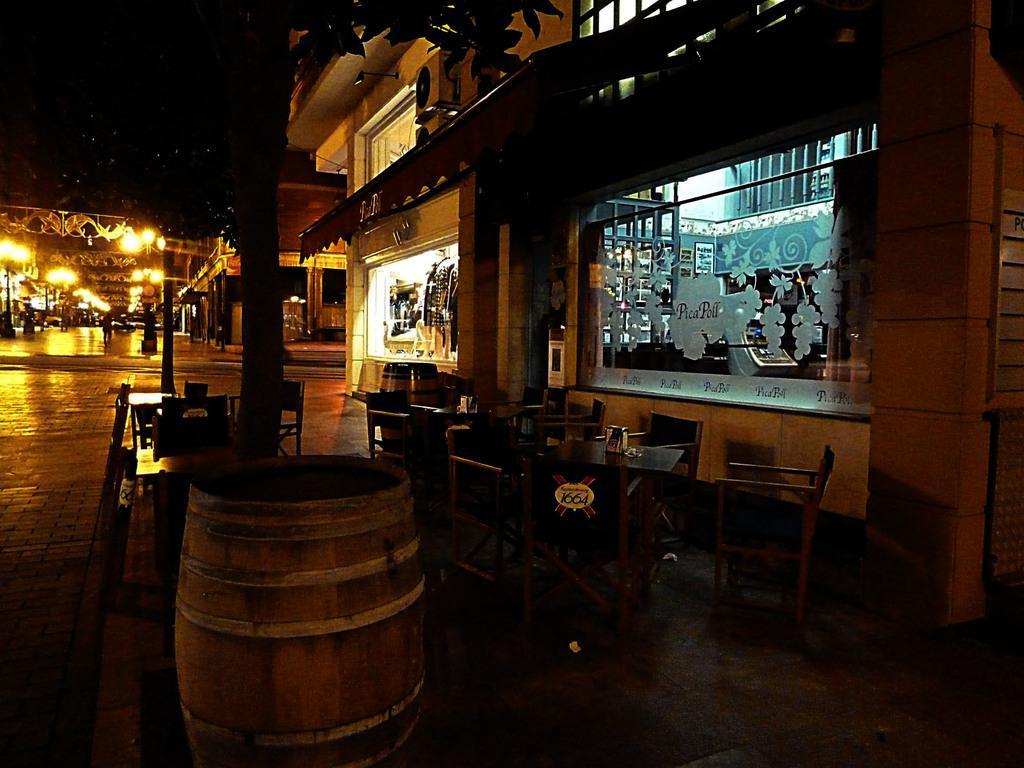How would you summarize this image in a sentence or two? Here we can see a table and chairs on the ground, and in front here is the building, and here is the tree, and here are the lights. 